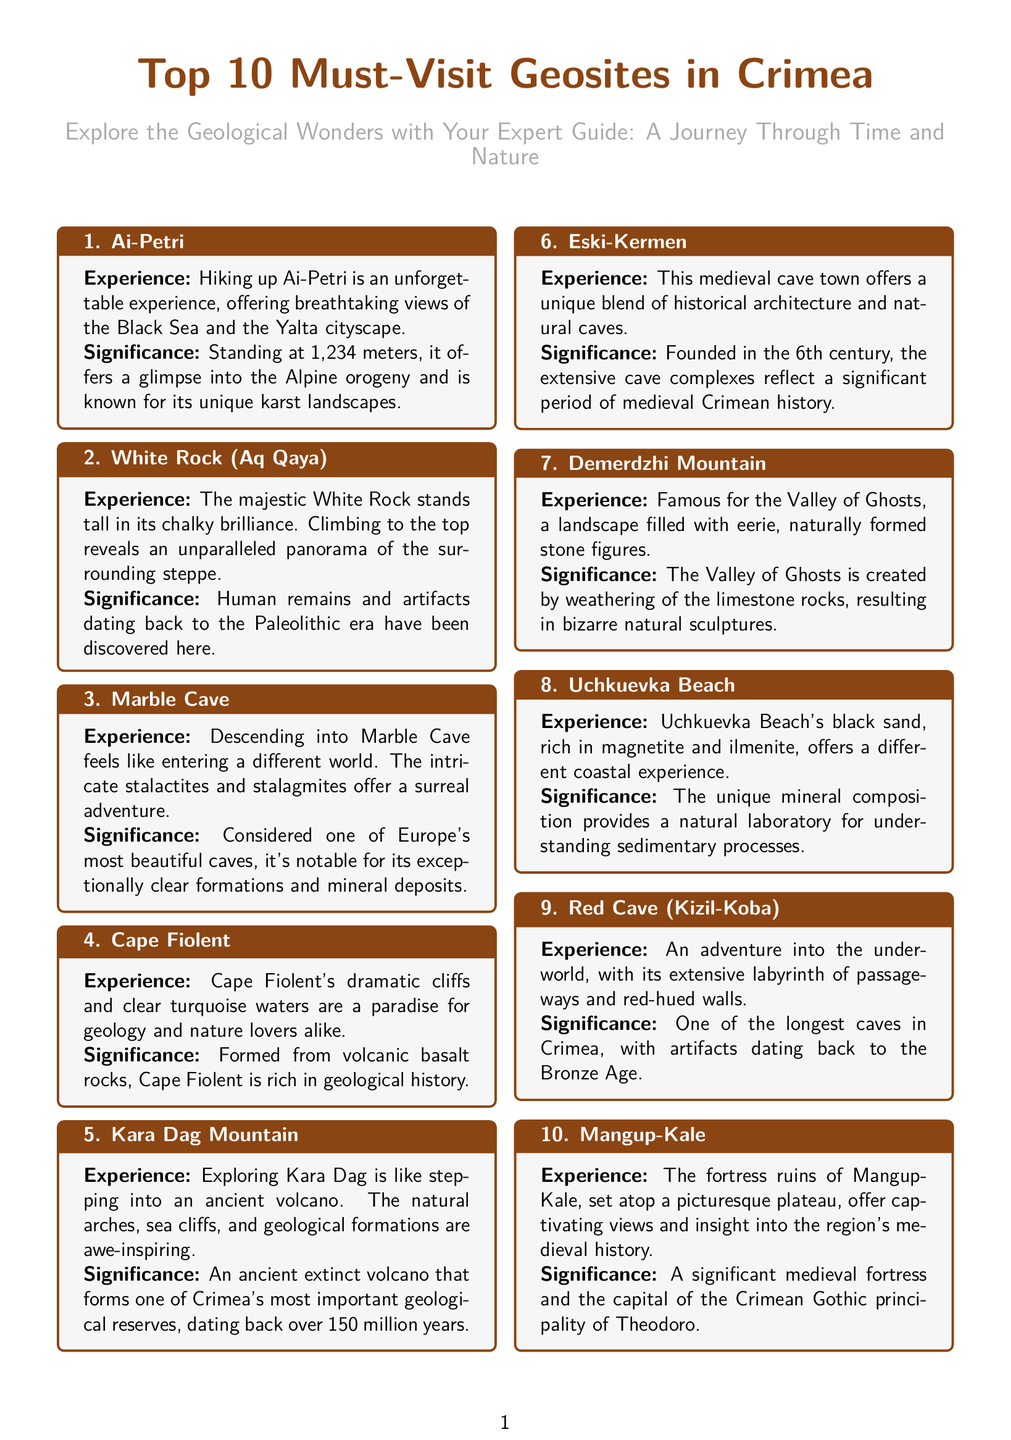What is the title of the document? The title of the document is stated prominently at the top of the layout.
Answer: Top 10 Must-Visit Geosites in Crimea How many geosites are featured in the document? The document is structured to showcase a list of ten specific geosites.
Answer: 10 What is the height of Ai-Petri? The height of Ai-Petri is provided directly in the description of the geosite.
Answer: 1,234 meters Which geosite is known for its "Valley of Ghosts"? The specific geosite associated with this unique geographical feature is mentioned in its description.
Answer: Demerdzhi Mountain What type of rock forms Cape Fiolent? The document highlights the geological formation type of the featured geosite.
Answer: Volcanic basalt rocks Which geosite has artifacts dating back to the Bronze Age? The description of one of the geosites specifically mentions this historical period associated with artifacts.
Answer: Red Cave (Kizil-Koba) What is special about Uchkuevka Beach's sand? The unique characteristic of the sand at this geosite is detailed in its significance description.
Answer: Black sand rich in magnetite and ilmenite What is the highest significance of Kara Dag Mountain? The document highlights Kara Dag Mountain's geological importance in its description.
Answer: One of Crimea's most important geological reserves Which geosite was founded in the 6th century? The historical foundation date is provided in the significance description of the respective geosite.
Answer: Eski-Kermen 